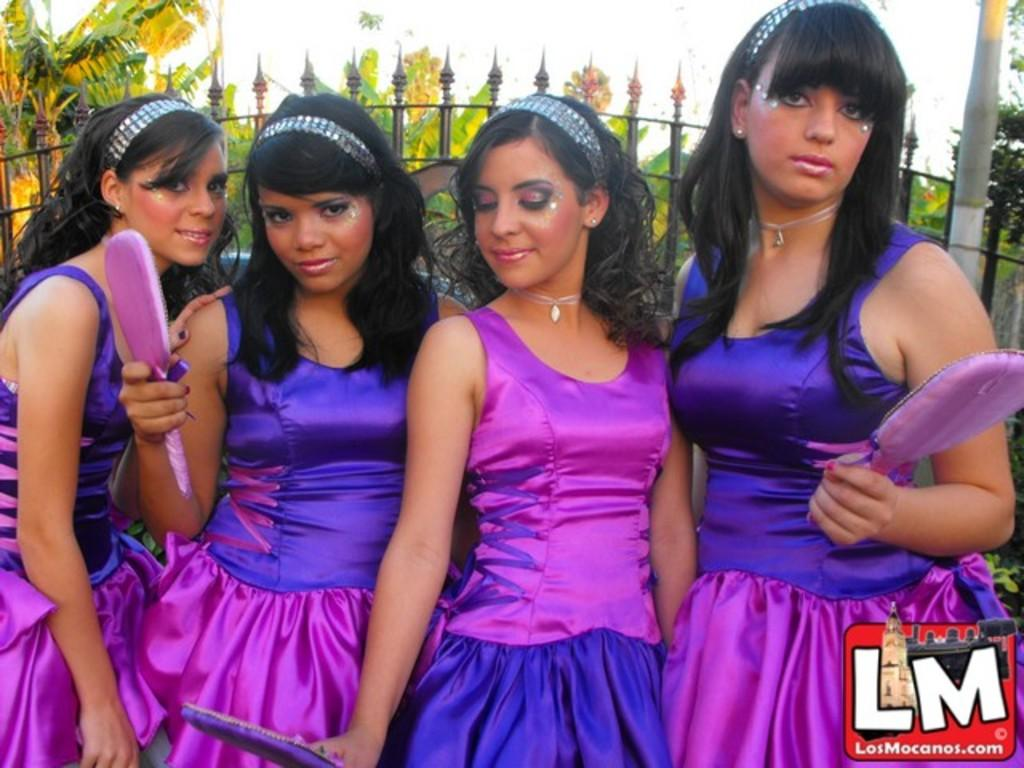How many women are present in the image? There are four women in the image. What are the women wearing? The women are wearing dresses. What are the women holding in their hands? The women are holding objects in their hands. What can be seen in the background of the image? There is a metal fence, a group of trees, and the sky visible in the background of the image. Can you describe the fog in the image? There is no fog present in the image. How many hands are visible in the image? The number of hands visible in the image cannot be determined without knowing the specific objects the women are holding. 